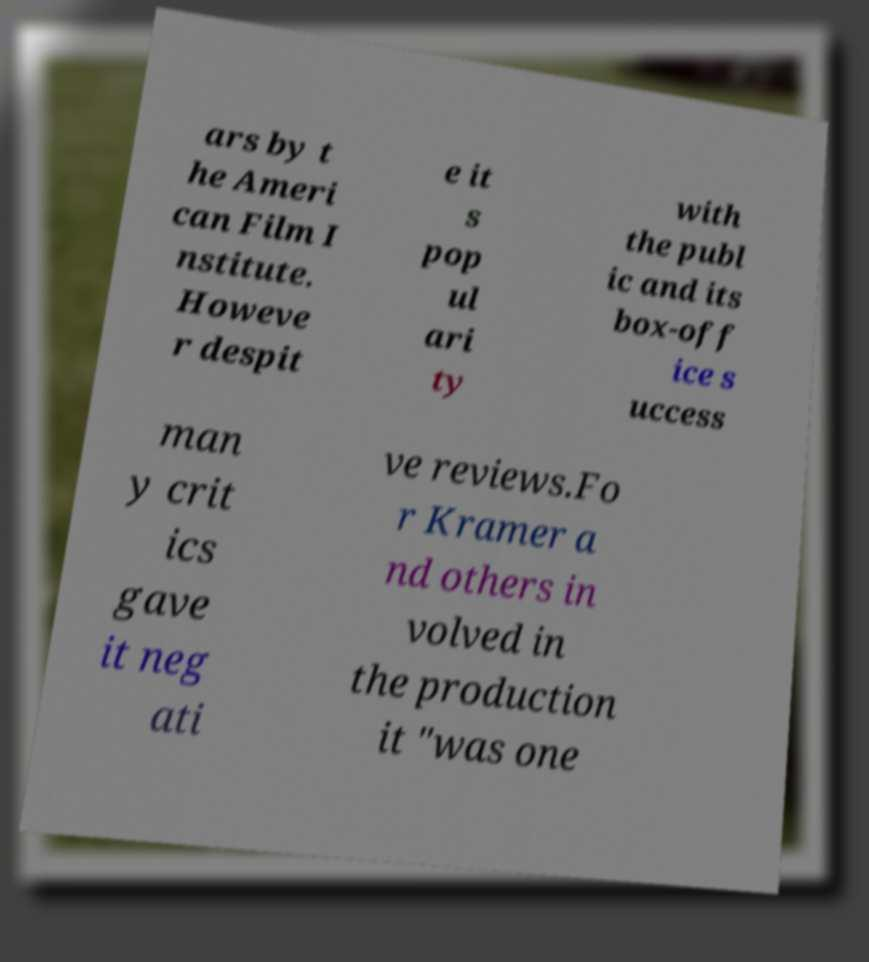For documentation purposes, I need the text within this image transcribed. Could you provide that? ars by t he Ameri can Film I nstitute. Howeve r despit e it s pop ul ari ty with the publ ic and its box-off ice s uccess man y crit ics gave it neg ati ve reviews.Fo r Kramer a nd others in volved in the production it "was one 